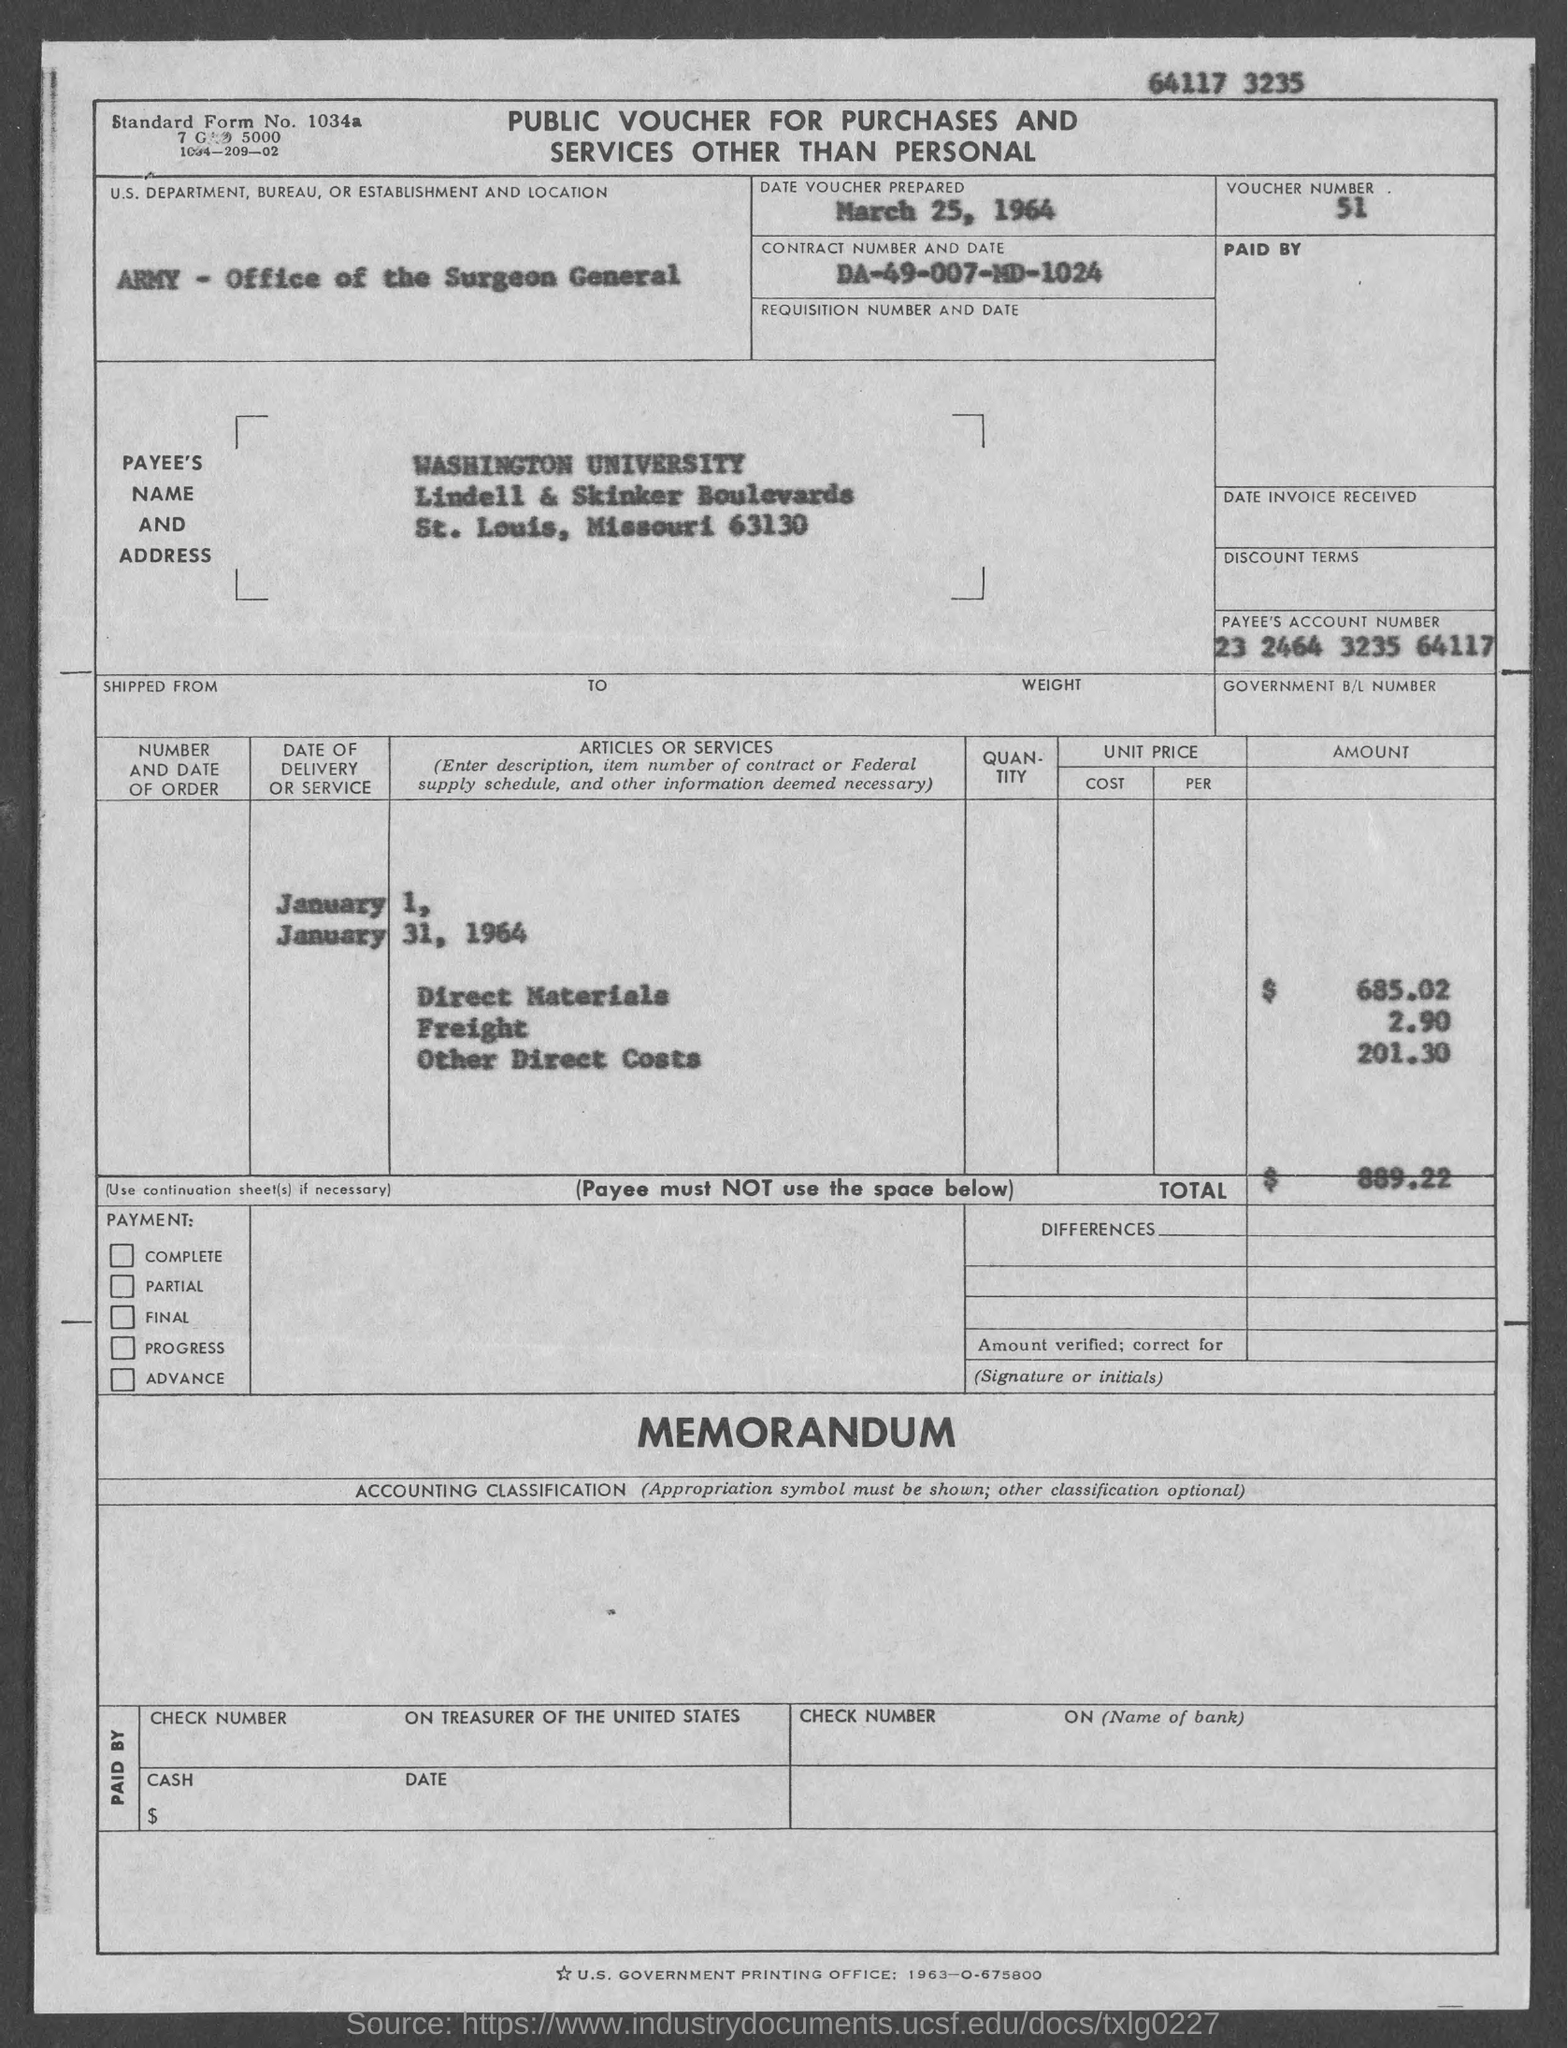List a handful of essential elements in this visual. The voucher number given in the document is 51. The standard form number appearing on the voucher is 1034a... The date of the voucher prepared is March 25, 1964. A public voucher is provided for purchases and services that are not personal in nature. The information provided in the voucher is "What is the Contract No. given in the voucher? da-49-007-md-1024..". 